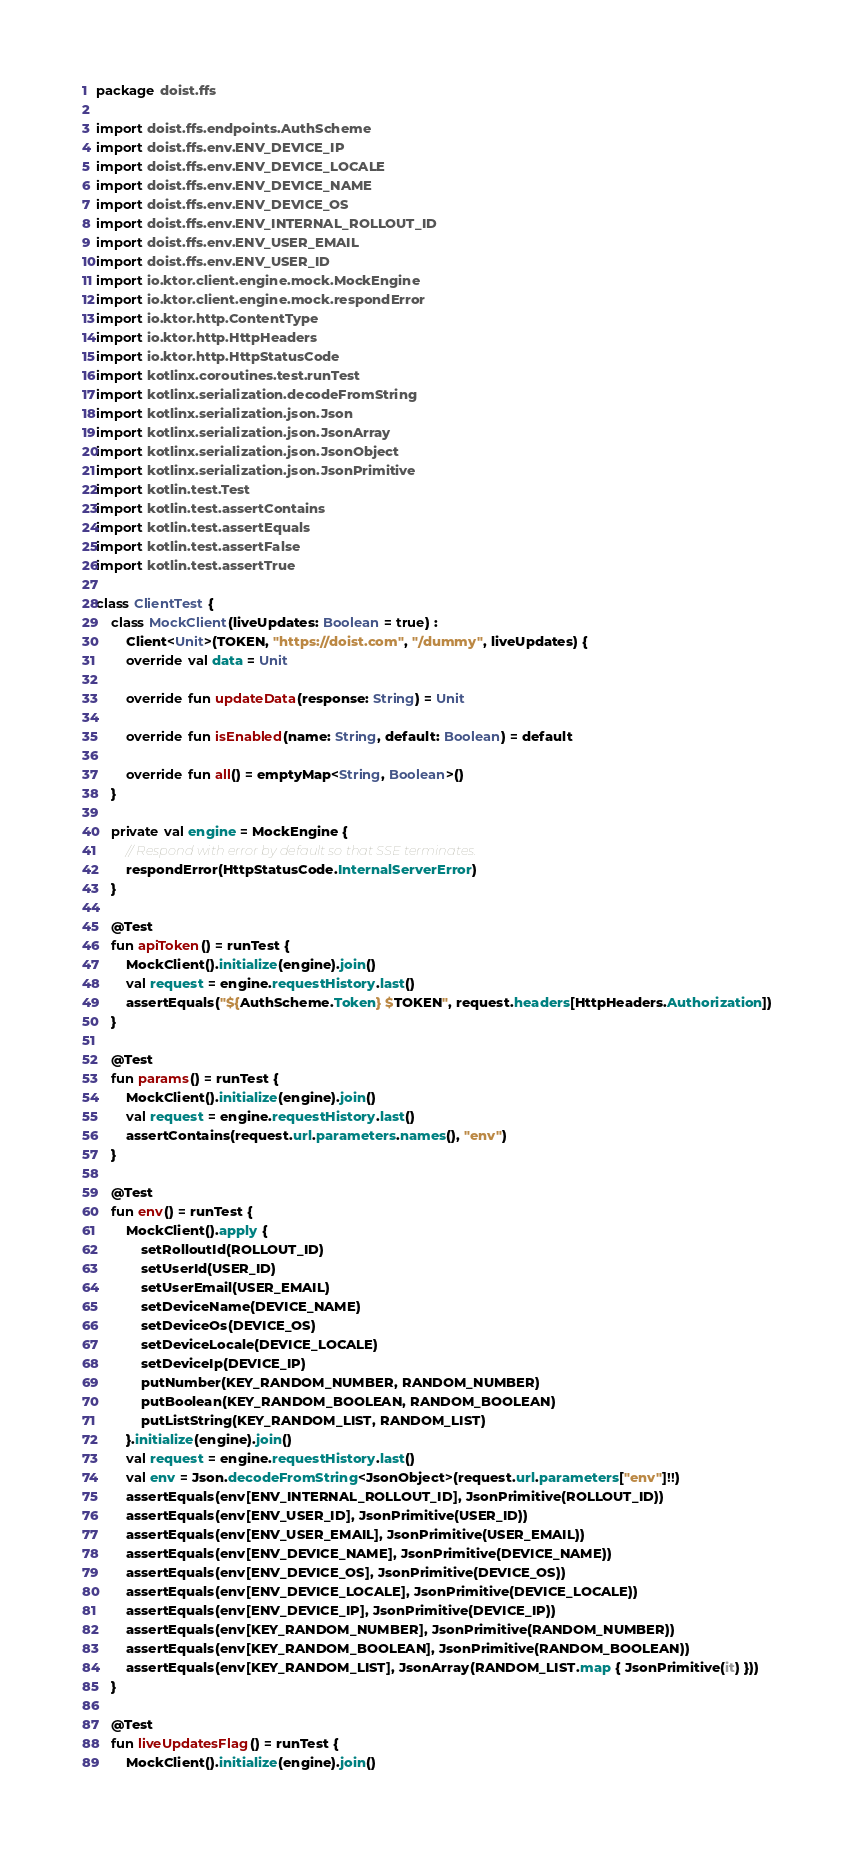<code> <loc_0><loc_0><loc_500><loc_500><_Kotlin_>package doist.ffs

import doist.ffs.endpoints.AuthScheme
import doist.ffs.env.ENV_DEVICE_IP
import doist.ffs.env.ENV_DEVICE_LOCALE
import doist.ffs.env.ENV_DEVICE_NAME
import doist.ffs.env.ENV_DEVICE_OS
import doist.ffs.env.ENV_INTERNAL_ROLLOUT_ID
import doist.ffs.env.ENV_USER_EMAIL
import doist.ffs.env.ENV_USER_ID
import io.ktor.client.engine.mock.MockEngine
import io.ktor.client.engine.mock.respondError
import io.ktor.http.ContentType
import io.ktor.http.HttpHeaders
import io.ktor.http.HttpStatusCode
import kotlinx.coroutines.test.runTest
import kotlinx.serialization.decodeFromString
import kotlinx.serialization.json.Json
import kotlinx.serialization.json.JsonArray
import kotlinx.serialization.json.JsonObject
import kotlinx.serialization.json.JsonPrimitive
import kotlin.test.Test
import kotlin.test.assertContains
import kotlin.test.assertEquals
import kotlin.test.assertFalse
import kotlin.test.assertTrue

class ClientTest {
    class MockClient(liveUpdates: Boolean = true) :
        Client<Unit>(TOKEN, "https://doist.com", "/dummy", liveUpdates) {
        override val data = Unit

        override fun updateData(response: String) = Unit

        override fun isEnabled(name: String, default: Boolean) = default

        override fun all() = emptyMap<String, Boolean>()
    }

    private val engine = MockEngine {
        // Respond with error by default so that SSE terminates.
        respondError(HttpStatusCode.InternalServerError)
    }

    @Test
    fun apiToken() = runTest {
        MockClient().initialize(engine).join()
        val request = engine.requestHistory.last()
        assertEquals("${AuthScheme.Token} $TOKEN", request.headers[HttpHeaders.Authorization])
    }

    @Test
    fun params() = runTest {
        MockClient().initialize(engine).join()
        val request = engine.requestHistory.last()
        assertContains(request.url.parameters.names(), "env")
    }

    @Test
    fun env() = runTest {
        MockClient().apply {
            setRolloutId(ROLLOUT_ID)
            setUserId(USER_ID)
            setUserEmail(USER_EMAIL)
            setDeviceName(DEVICE_NAME)
            setDeviceOs(DEVICE_OS)
            setDeviceLocale(DEVICE_LOCALE)
            setDeviceIp(DEVICE_IP)
            putNumber(KEY_RANDOM_NUMBER, RANDOM_NUMBER)
            putBoolean(KEY_RANDOM_BOOLEAN, RANDOM_BOOLEAN)
            putListString(KEY_RANDOM_LIST, RANDOM_LIST)
        }.initialize(engine).join()
        val request = engine.requestHistory.last()
        val env = Json.decodeFromString<JsonObject>(request.url.parameters["env"]!!)
        assertEquals(env[ENV_INTERNAL_ROLLOUT_ID], JsonPrimitive(ROLLOUT_ID))
        assertEquals(env[ENV_USER_ID], JsonPrimitive(USER_ID))
        assertEquals(env[ENV_USER_EMAIL], JsonPrimitive(USER_EMAIL))
        assertEquals(env[ENV_DEVICE_NAME], JsonPrimitive(DEVICE_NAME))
        assertEquals(env[ENV_DEVICE_OS], JsonPrimitive(DEVICE_OS))
        assertEquals(env[ENV_DEVICE_LOCALE], JsonPrimitive(DEVICE_LOCALE))
        assertEquals(env[ENV_DEVICE_IP], JsonPrimitive(DEVICE_IP))
        assertEquals(env[KEY_RANDOM_NUMBER], JsonPrimitive(RANDOM_NUMBER))
        assertEquals(env[KEY_RANDOM_BOOLEAN], JsonPrimitive(RANDOM_BOOLEAN))
        assertEquals(env[KEY_RANDOM_LIST], JsonArray(RANDOM_LIST.map { JsonPrimitive(it) }))
    }

    @Test
    fun liveUpdatesFlag() = runTest {
        MockClient().initialize(engine).join()</code> 